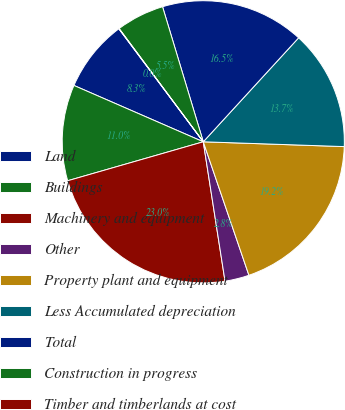Convert chart. <chart><loc_0><loc_0><loc_500><loc_500><pie_chart><fcel>Land<fcel>Buildings<fcel>Machinery and equipment<fcel>Other<fcel>Property plant and equipment<fcel>Less Accumulated depreciation<fcel>Total<fcel>Construction in progress<fcel>Timber and timberlands at cost<nl><fcel>8.25%<fcel>10.99%<fcel>23.01%<fcel>2.78%<fcel>19.21%<fcel>13.73%<fcel>16.47%<fcel>5.51%<fcel>0.04%<nl></chart> 